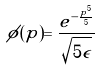Convert formula to latex. <formula><loc_0><loc_0><loc_500><loc_500>\phi ( p ) = \frac { e ^ { - \frac { p ^ { 5 } } { 5 } } } { \sqrt { 5 \epsilon } }</formula> 